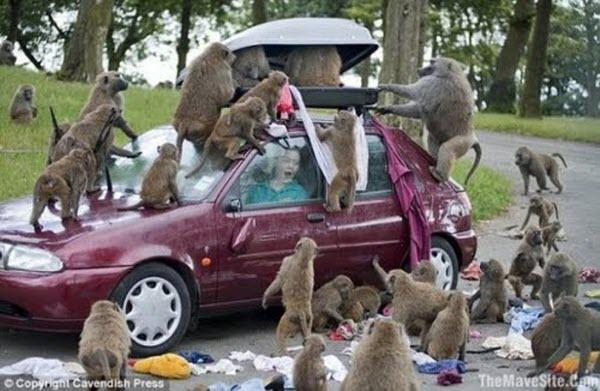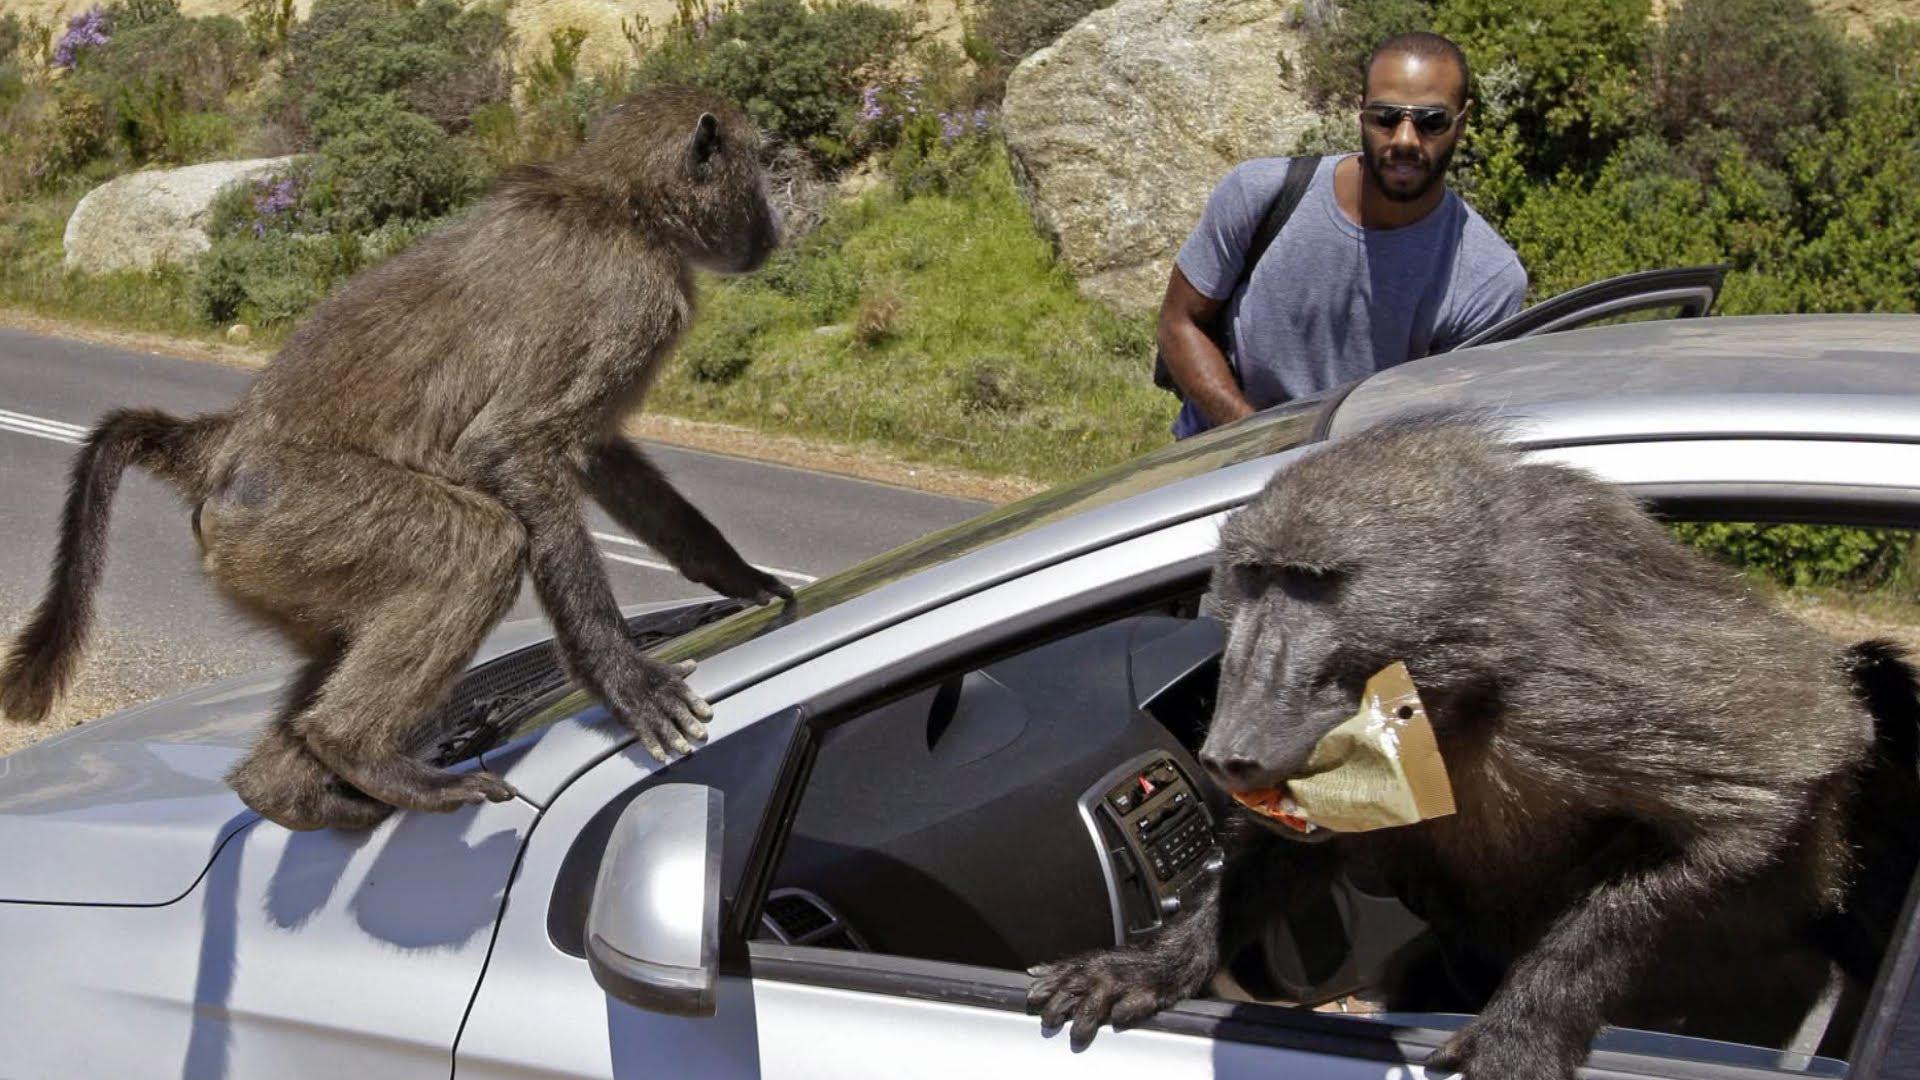The first image is the image on the left, the second image is the image on the right. Assess this claim about the two images: "There are monkeys on top of a vehicle's roof in at least one of the images.". Correct or not? Answer yes or no. Yes. The first image is the image on the left, the second image is the image on the right. Given the left and right images, does the statement "The left image contains a woman carrying groceries." hold true? Answer yes or no. No. 